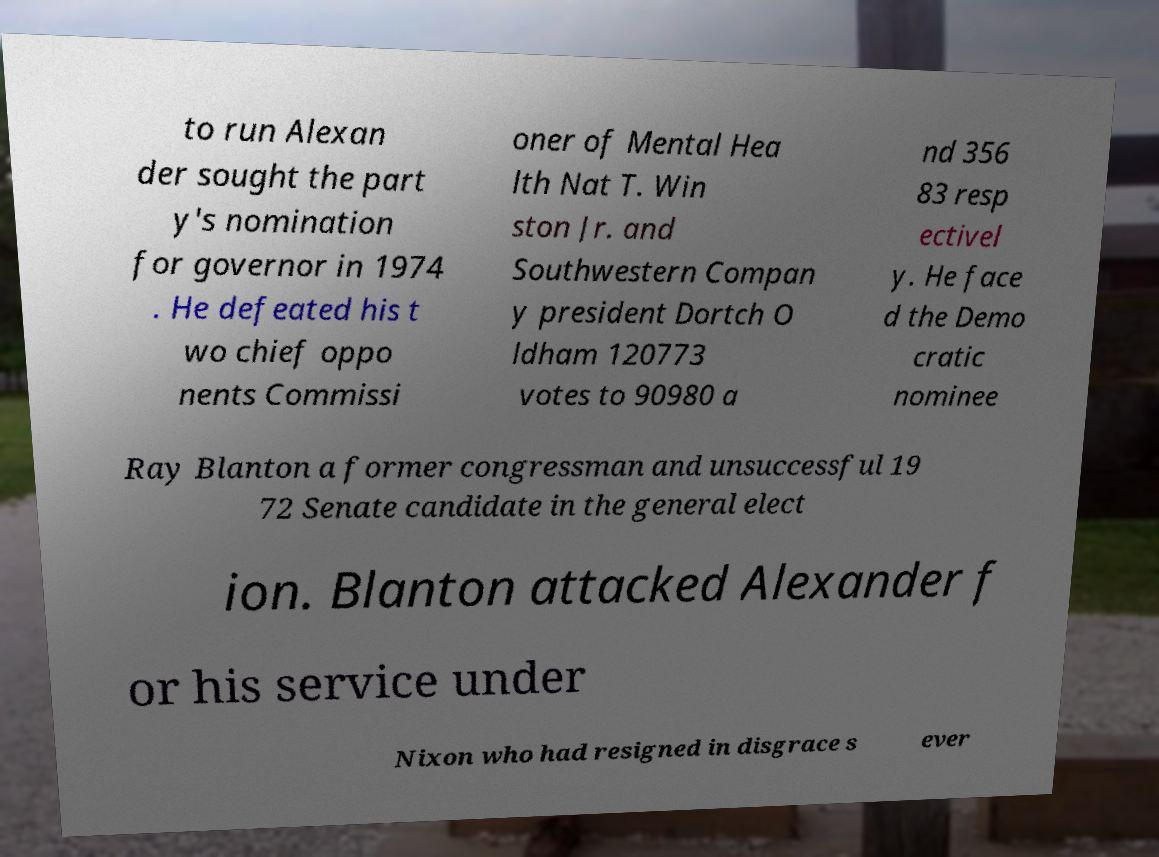Please identify and transcribe the text found in this image. to run Alexan der sought the part y's nomination for governor in 1974 . He defeated his t wo chief oppo nents Commissi oner of Mental Hea lth Nat T. Win ston Jr. and Southwestern Compan y president Dortch O ldham 120773 votes to 90980 a nd 356 83 resp ectivel y. He face d the Demo cratic nominee Ray Blanton a former congressman and unsuccessful 19 72 Senate candidate in the general elect ion. Blanton attacked Alexander f or his service under Nixon who had resigned in disgrace s ever 